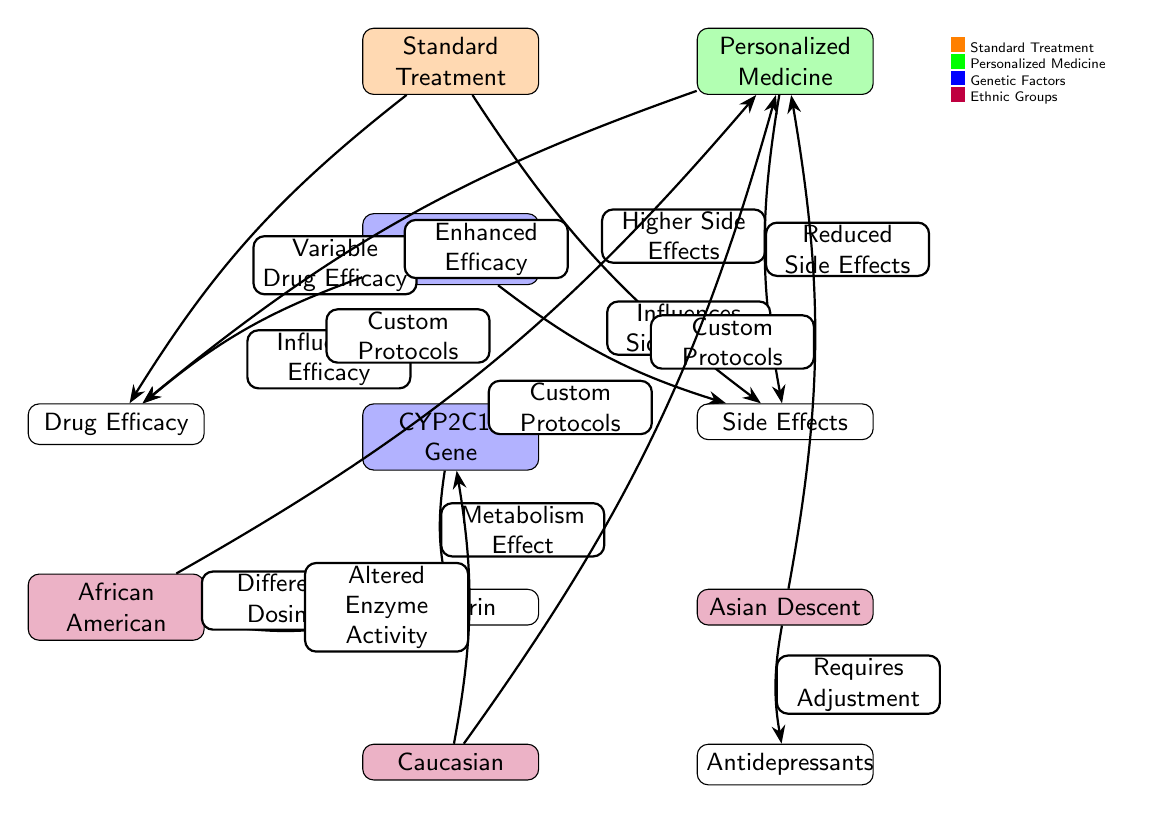What are the two main types of treatments depicted in the diagram? The diagram shows two main types of treatments which are Standard Treatment and Personalized Medicine. These are represented as the two main nodes at the top of the diagram.
Answer: Standard Treatment, Personalized Medicine What influence does Genetic Diversity have on Drug Efficacy? According to the diagram, Genetic Diversity influences Drug Efficacy as indicated by the edge labeled "Influences Efficacy" connecting Genetic Diversity to Drug Efficacy.
Answer: Influences Efficacy How many ethnic backgrounds are referenced in relation to Warfarin? There are three ethnic backgrounds referenced in relation to Warfarin: African American, Asian Descent, and Caucasian. Each is linked to Warfarin through edges that describe their specific effects or protocols.
Answer: Three What is the effect of the CYP2C19 gene on Warfarin? The CYP2C19 gene affects Warfarin by changing the metabolism, as indicated by the edge labeled "Metabolism Effect" that connects the CYP2C19 Gene to Warfarin.
Answer: Metabolism Effect What connection is made between Personalized Medicine and ethnic backgrounds? Personalized Medicine is connected to ethnic backgrounds through the edges labeled "Custom Protocols," which link African American, Asian Descent, and Caucasian to Personalized Medicine, implying tailored treatment plans for each group.
Answer: Custom Protocols Which treatment type is associated with higher side effects? The Standard Treatment type is associated with higher side effects, as stated in the edge labeled "Higher Side Effects" connecting Standard Treatment to Side Effects.
Answer: Higher Side Effects What does the edge labeled "Requires Adjustment" imply in the context of Asian Descent? The edge labeled "Requires Adjustment" implies that the treatment for individuals of Asian Descent needs to be modified or adjusted, which is indicated in the context of antidepressants, as shown in the diagram.
Answer: Requires Adjustment What advantage does Personalized Medicine have over Standard Treatment regarding side effects? The advantage of Personalized Medicine over Standard Treatment regarding side effects is highlighted as "Reduced Side Effects," indicating a significant benefit from personalized treatment approaches.
Answer: Reduced Side Effects What is the primary outcome of applying Personalized Medicine according to the diagram? The primary outcomes of applying Personalized Medicine according to the diagram are "Enhanced Efficacy" and "Reduced Side Effects," demonstrating the benefits of customized treatment plans based on genetic diversity and ethnicity.
Answer: Enhanced Efficacy, Reduced Side Effects 